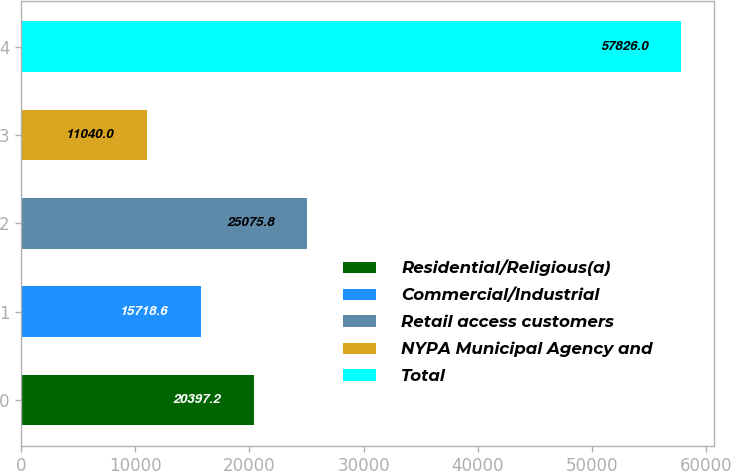Convert chart. <chart><loc_0><loc_0><loc_500><loc_500><bar_chart><fcel>Residential/Religious(a)<fcel>Commercial/Industrial<fcel>Retail access customers<fcel>NYPA Municipal Agency and<fcel>Total<nl><fcel>20397.2<fcel>15718.6<fcel>25075.8<fcel>11040<fcel>57826<nl></chart> 